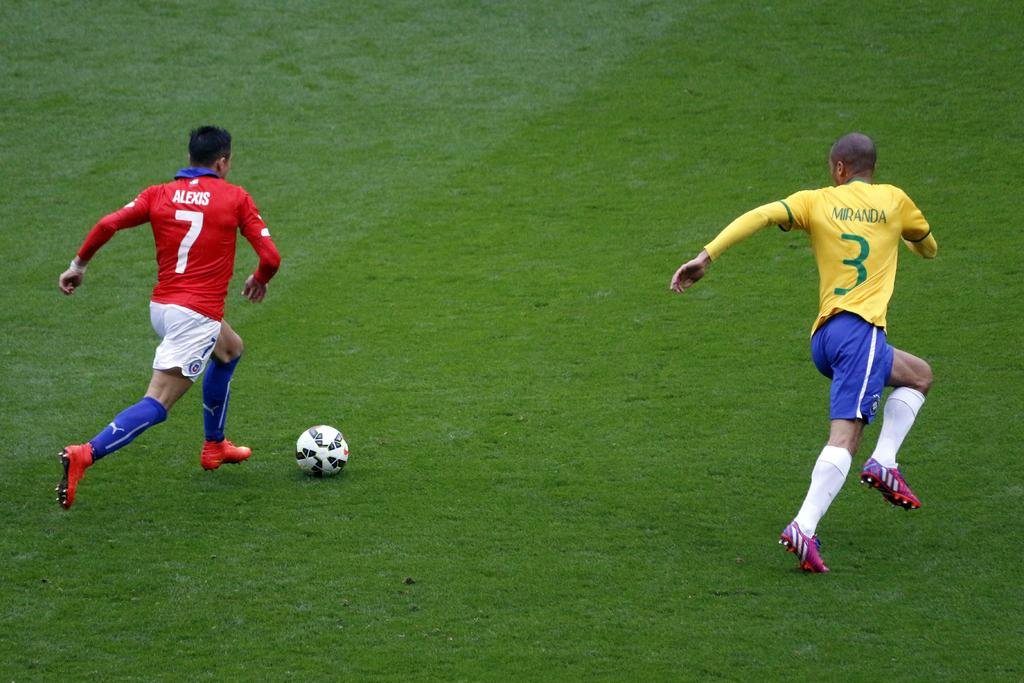<image>
Write a terse but informative summary of the picture. Miranda #3 tries to get in front of Alexis #7 in a soccer game. 